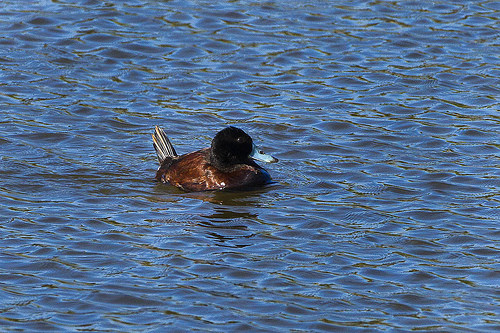<image>
Is the duck to the left of the sea? No. The duck is not to the left of the sea. From this viewpoint, they have a different horizontal relationship. 